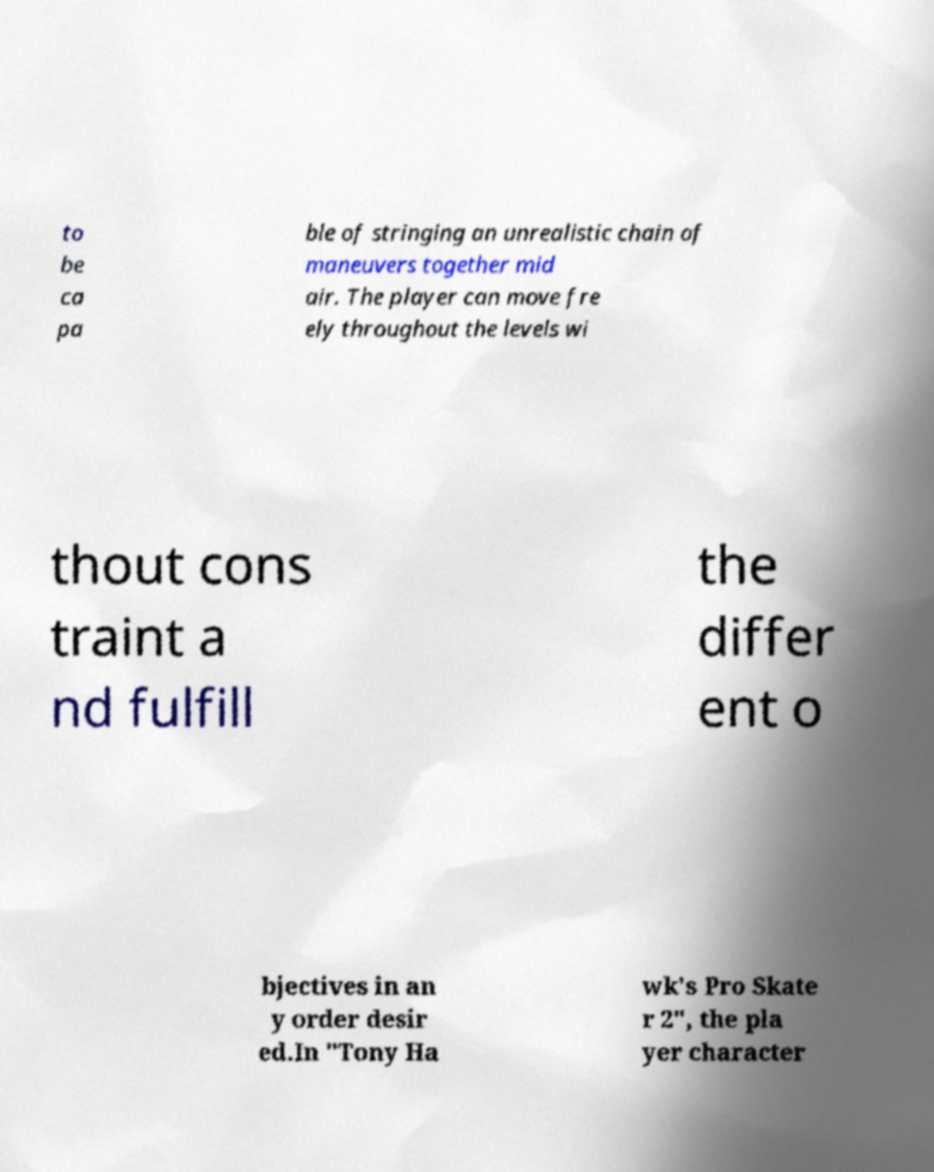What messages or text are displayed in this image? I need them in a readable, typed format. to be ca pa ble of stringing an unrealistic chain of maneuvers together mid air. The player can move fre ely throughout the levels wi thout cons traint a nd fulfill the differ ent o bjectives in an y order desir ed.In "Tony Ha wk's Pro Skate r 2", the pla yer character 